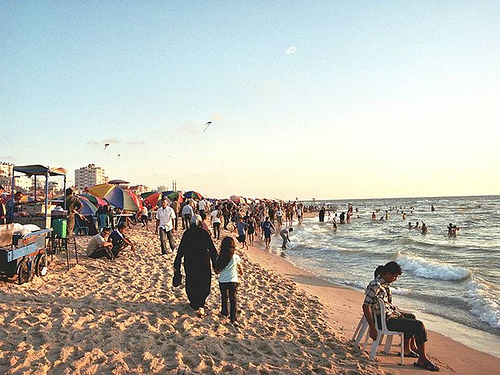Is the woman to the left of the people on the left of the image? Yes, the woman is walking to the left of the main groups of people scattered near the left side of the beach setting. 